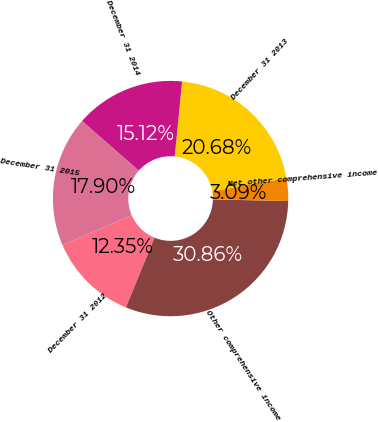Convert chart. <chart><loc_0><loc_0><loc_500><loc_500><pie_chart><fcel>December 31 2012<fcel>Other comprehensive income<fcel>Net other comprehensive income<fcel>December 31 2013<fcel>December 31 2014<fcel>December 31 2015<nl><fcel>12.35%<fcel>30.86%<fcel>3.09%<fcel>20.68%<fcel>15.12%<fcel>17.9%<nl></chart> 